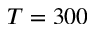Convert formula to latex. <formula><loc_0><loc_0><loc_500><loc_500>T = 3 0 0</formula> 